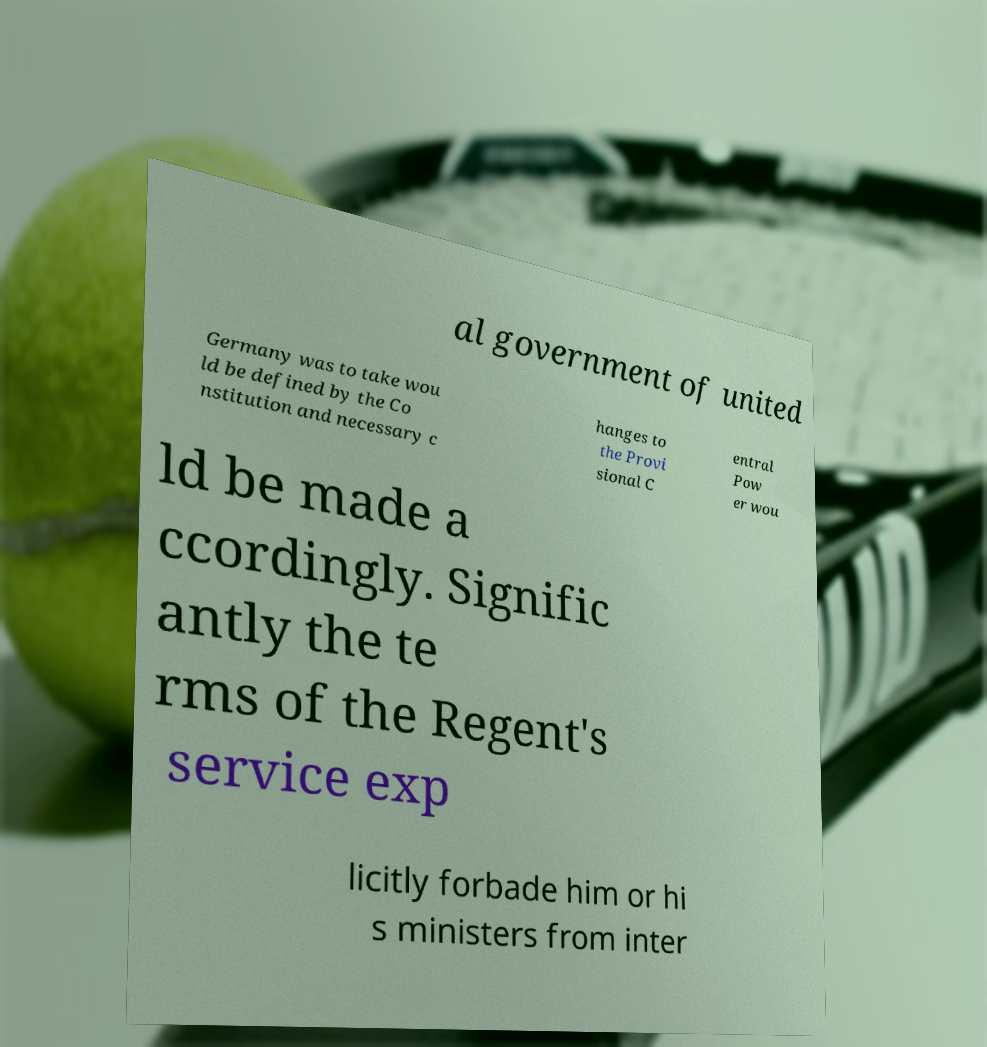There's text embedded in this image that I need extracted. Can you transcribe it verbatim? al government of united Germany was to take wou ld be defined by the Co nstitution and necessary c hanges to the Provi sional C entral Pow er wou ld be made a ccordingly. Signific antly the te rms of the Regent's service exp licitly forbade him or hi s ministers from inter 